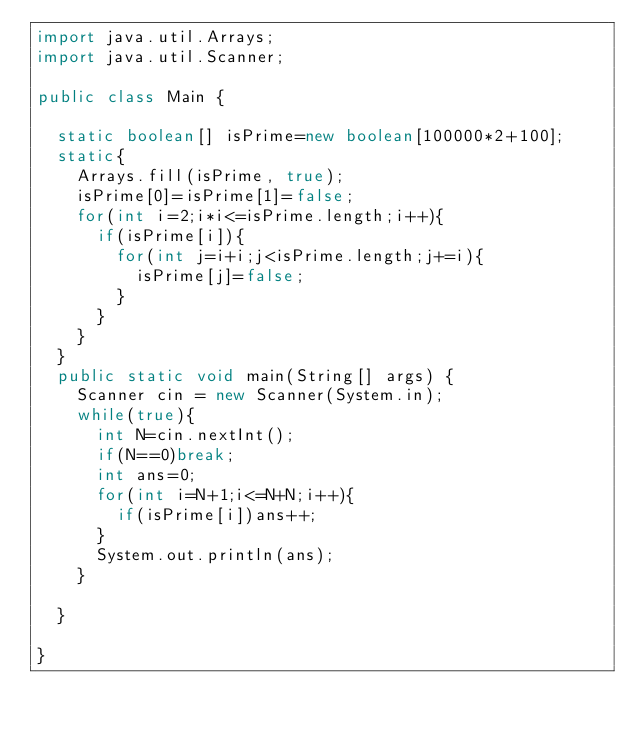Convert code to text. <code><loc_0><loc_0><loc_500><loc_500><_Java_>import java.util.Arrays;
import java.util.Scanner;

public class Main {

	static boolean[] isPrime=new boolean[100000*2+100];
	static{
		Arrays.fill(isPrime, true);
		isPrime[0]=isPrime[1]=false;
		for(int i=2;i*i<=isPrime.length;i++){
			if(isPrime[i]){
				for(int j=i+i;j<isPrime.length;j+=i){
					isPrime[j]=false;
				}
			}
		}
	}
	public static void main(String[] args) {
		Scanner cin = new Scanner(System.in);
		while(true){
			int N=cin.nextInt();
			if(N==0)break;
			int ans=0;
			for(int i=N+1;i<=N+N;i++){
				if(isPrime[i])ans++;
			}
			System.out.println(ans);
		}

	}

}</code> 